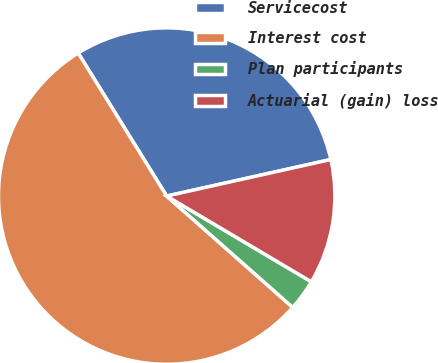Convert chart. <chart><loc_0><loc_0><loc_500><loc_500><pie_chart><fcel>Servicecost<fcel>Interest cost<fcel>Plan participants<fcel>Actuarial (gain) loss<nl><fcel>30.33%<fcel>54.67%<fcel>3.0%<fcel>12.0%<nl></chart> 